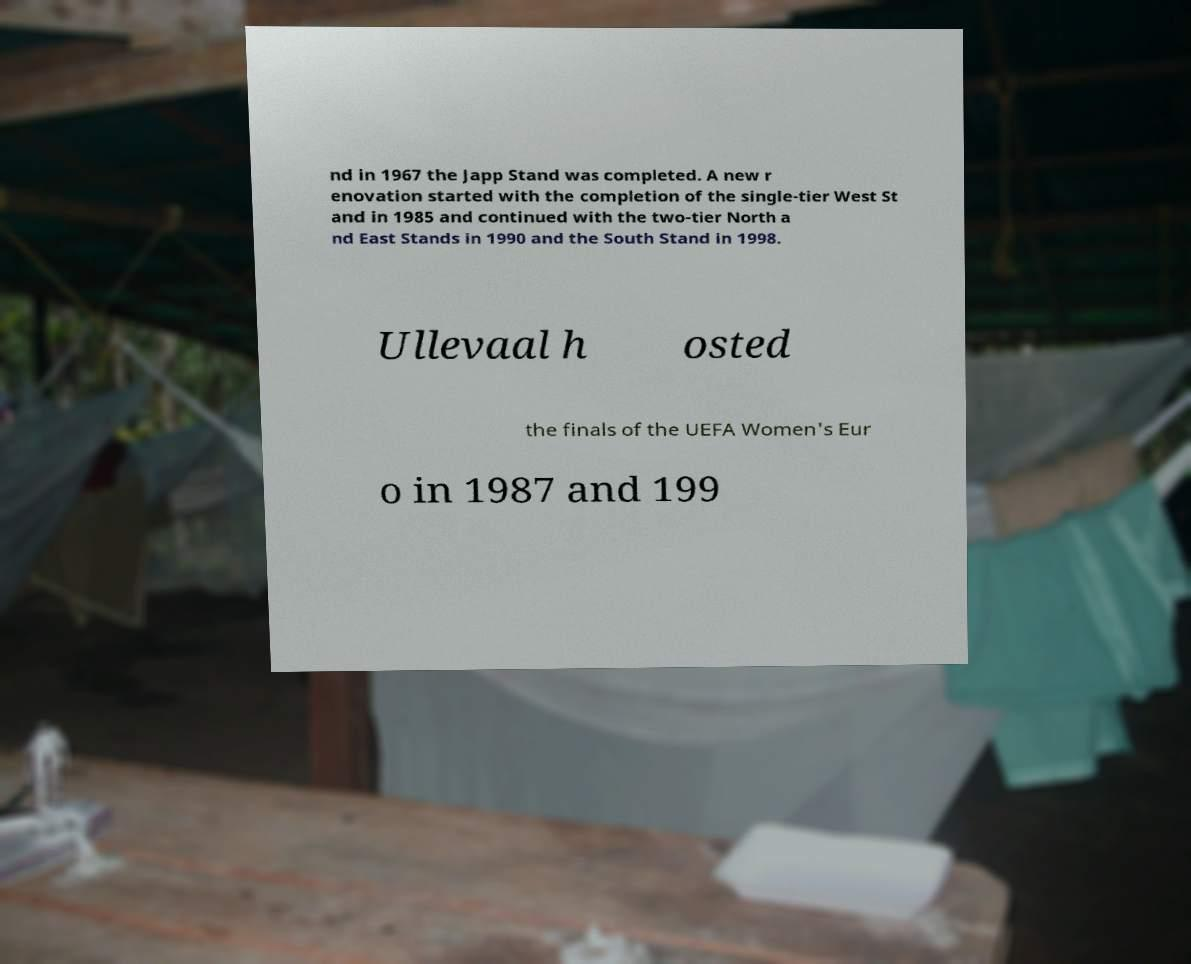Can you accurately transcribe the text from the provided image for me? nd in 1967 the Japp Stand was completed. A new r enovation started with the completion of the single-tier West St and in 1985 and continued with the two-tier North a nd East Stands in 1990 and the South Stand in 1998. Ullevaal h osted the finals of the UEFA Women's Eur o in 1987 and 199 